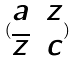Convert formula to latex. <formula><loc_0><loc_0><loc_500><loc_500>( \begin{matrix} a & z \\ \overline { z } & c \end{matrix} )</formula> 